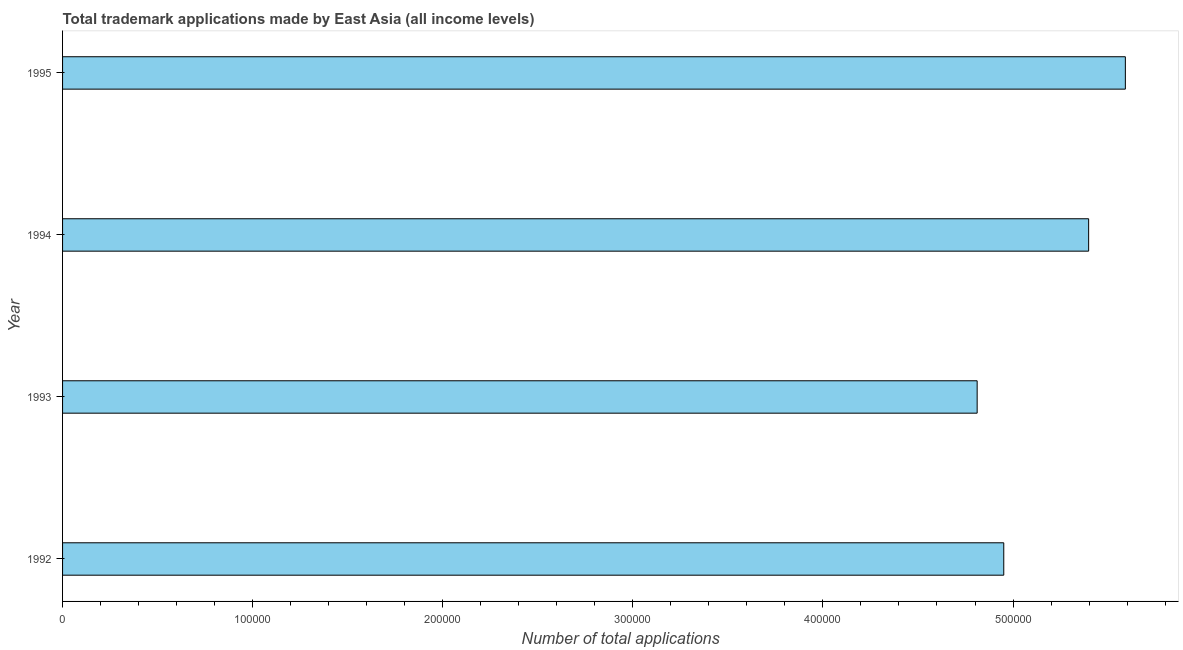Does the graph contain any zero values?
Your answer should be very brief. No. Does the graph contain grids?
Your answer should be compact. No. What is the title of the graph?
Provide a succinct answer. Total trademark applications made by East Asia (all income levels). What is the label or title of the X-axis?
Keep it short and to the point. Number of total applications. What is the number of trademark applications in 1994?
Your answer should be compact. 5.40e+05. Across all years, what is the maximum number of trademark applications?
Offer a very short reply. 5.59e+05. Across all years, what is the minimum number of trademark applications?
Offer a very short reply. 4.81e+05. In which year was the number of trademark applications minimum?
Offer a very short reply. 1993. What is the sum of the number of trademark applications?
Offer a terse response. 2.08e+06. What is the difference between the number of trademark applications in 1994 and 1995?
Provide a succinct answer. -1.93e+04. What is the average number of trademark applications per year?
Your answer should be compact. 5.19e+05. What is the median number of trademark applications?
Offer a terse response. 5.17e+05. Is the difference between the number of trademark applications in 1993 and 1994 greater than the difference between any two years?
Offer a terse response. No. What is the difference between the highest and the second highest number of trademark applications?
Keep it short and to the point. 1.93e+04. Is the sum of the number of trademark applications in 1992 and 1994 greater than the maximum number of trademark applications across all years?
Offer a terse response. Yes. What is the difference between the highest and the lowest number of trademark applications?
Your answer should be compact. 7.80e+04. In how many years, is the number of trademark applications greater than the average number of trademark applications taken over all years?
Your answer should be very brief. 2. Are all the bars in the graph horizontal?
Make the answer very short. Yes. How many years are there in the graph?
Offer a very short reply. 4. What is the difference between two consecutive major ticks on the X-axis?
Give a very brief answer. 1.00e+05. Are the values on the major ticks of X-axis written in scientific E-notation?
Make the answer very short. No. What is the Number of total applications in 1992?
Make the answer very short. 4.95e+05. What is the Number of total applications of 1993?
Your answer should be compact. 4.81e+05. What is the Number of total applications in 1994?
Your response must be concise. 5.40e+05. What is the Number of total applications of 1995?
Your answer should be very brief. 5.59e+05. What is the difference between the Number of total applications in 1992 and 1993?
Your answer should be compact. 1.40e+04. What is the difference between the Number of total applications in 1992 and 1994?
Provide a succinct answer. -4.46e+04. What is the difference between the Number of total applications in 1992 and 1995?
Make the answer very short. -6.40e+04. What is the difference between the Number of total applications in 1993 and 1994?
Make the answer very short. -5.87e+04. What is the difference between the Number of total applications in 1993 and 1995?
Your response must be concise. -7.80e+04. What is the difference between the Number of total applications in 1994 and 1995?
Provide a succinct answer. -1.93e+04. What is the ratio of the Number of total applications in 1992 to that in 1994?
Provide a succinct answer. 0.92. What is the ratio of the Number of total applications in 1992 to that in 1995?
Provide a short and direct response. 0.89. What is the ratio of the Number of total applications in 1993 to that in 1994?
Give a very brief answer. 0.89. What is the ratio of the Number of total applications in 1993 to that in 1995?
Ensure brevity in your answer.  0.86. What is the ratio of the Number of total applications in 1994 to that in 1995?
Ensure brevity in your answer.  0.96. 